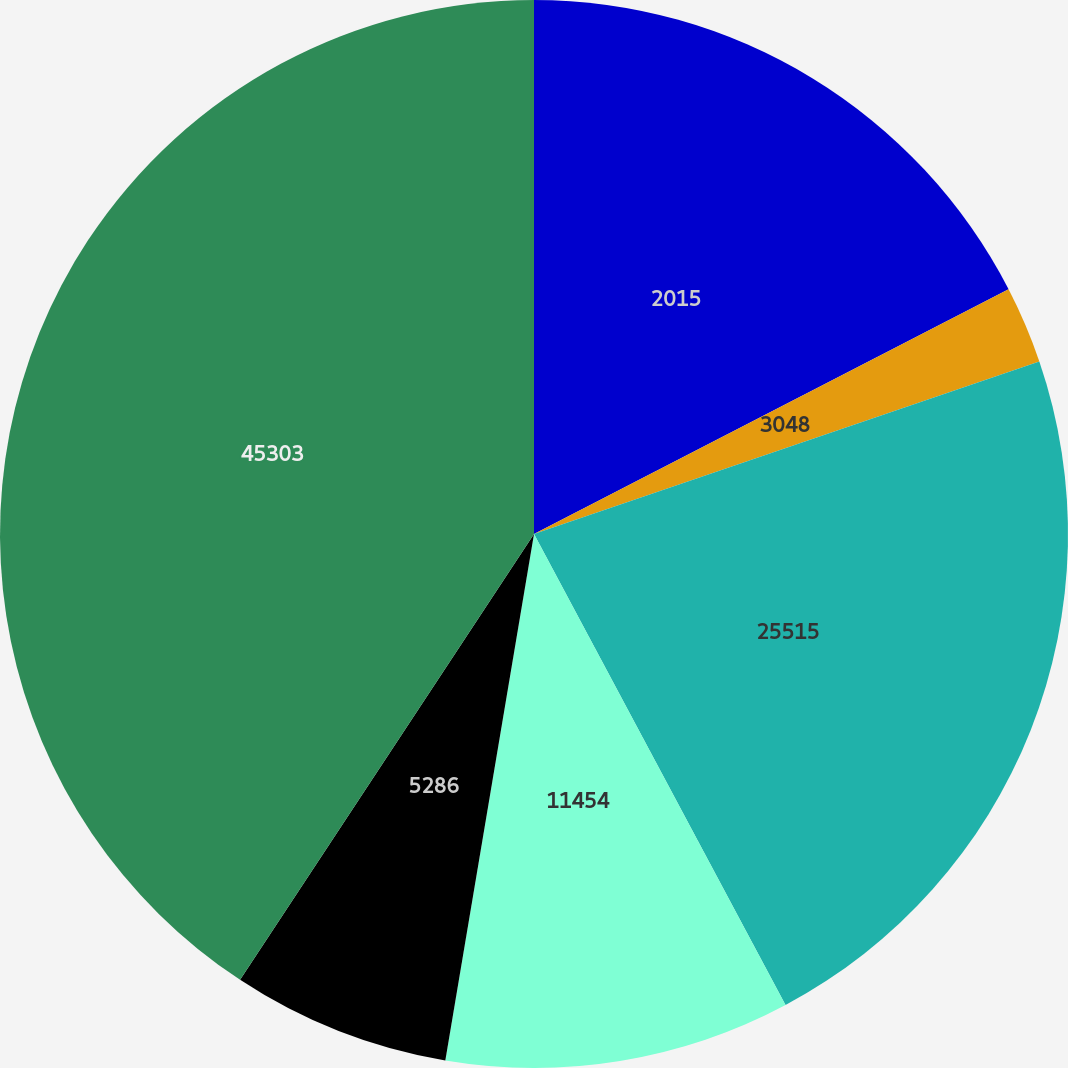Convert chart. <chart><loc_0><loc_0><loc_500><loc_500><pie_chart><fcel>2015<fcel>3048<fcel>25515<fcel>11454<fcel>5286<fcel>45303<nl><fcel>17.42%<fcel>2.34%<fcel>22.43%<fcel>10.46%<fcel>6.62%<fcel>40.72%<nl></chart> 